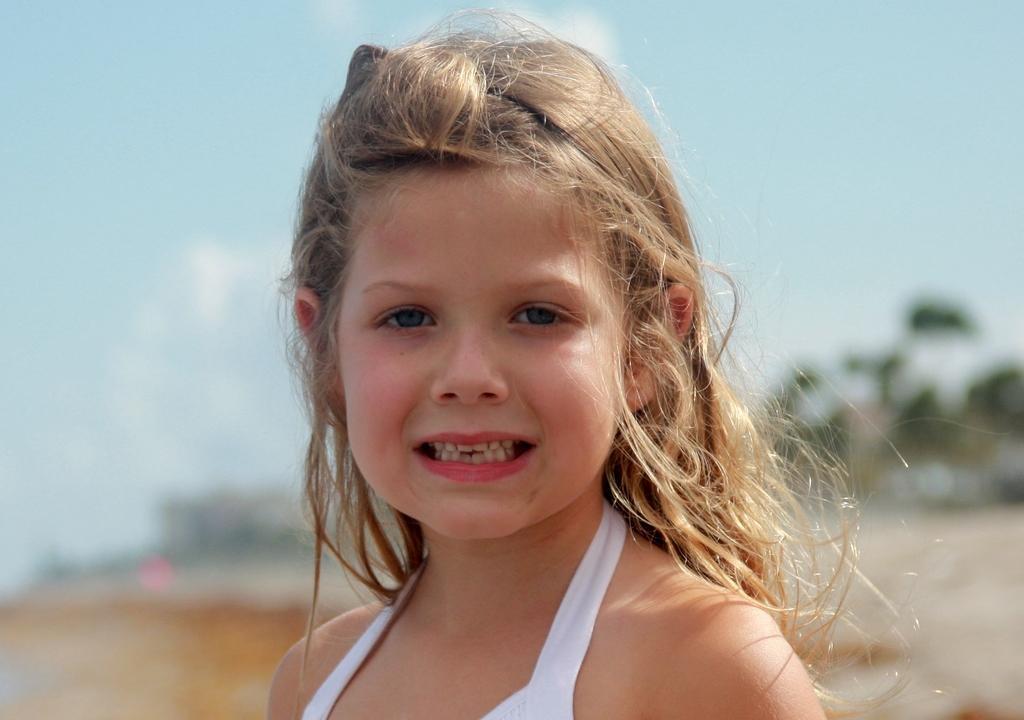In one or two sentences, can you explain what this image depicts? There is a small girl in the center of the image, it seems like trees and sky in the background area. 